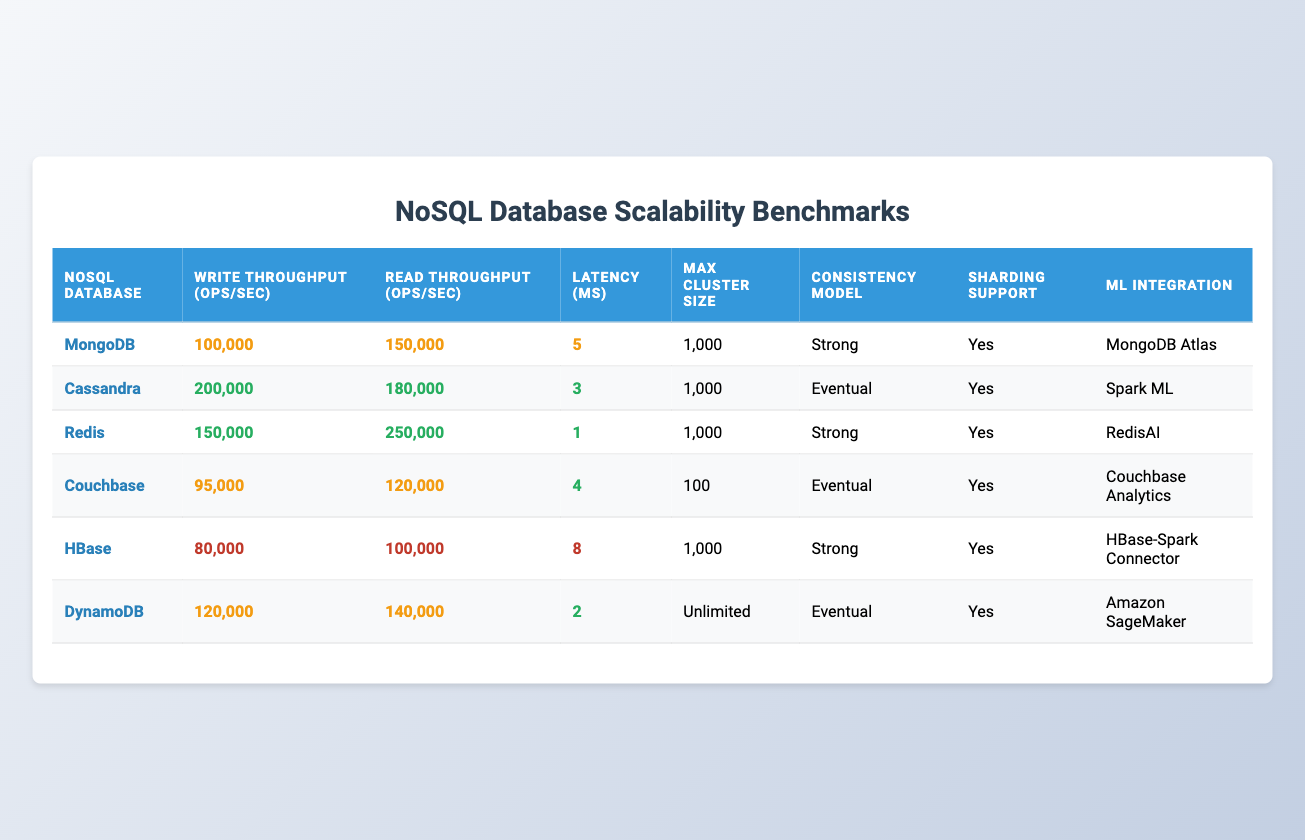What is the write throughput of Cassandra? By looking at the "Write Throughput (ops/sec)" column for Cassandra, the value is clearly listed as 200000 operations per second.
Answer: 200000 Which NoSQL database has the highest read throughput? Reviewing the "Read Throughput (ops/sec)" column, Redis has the highest value at 250000 operations per second.
Answer: Redis What is the average latency for the databases listed? The latencies are 5, 3, 1, 4, 8, and 2 milliseconds, respectively. Summing these values gives 5 + 3 + 1 + 4 + 8 + 2 = 23 ms. Dividing by the number of databases (6), the average latency is 23 / 6 = 3.83 ms.
Answer: 3.83 Is it true that all the NoSQL databases listed support sharding? The "Sharding Support" column for each database shows "Yes", confirming that it is indeed true that all listed databases support sharding.
Answer: Yes Which database has the strongest consistency model? From the "Consistency Model" column, both MongoDB, Redis, and HBase have a strong consistency model, whereas others have eventual consistency.
Answer: MongoDB, Redis, HBase What is the maximum cluster size for Couchbase? The "Max Cluster Size" column indicates that Couchbase can support a maximum cluster size of 100.
Answer: 100 Which NoSQL database has the lowest write throughput? By comparing the "Write Throughput (ops/sec)" column, HBase has the lowest value at 80000 operations per second.
Answer: HBase What is the difference in latency between Redis and HBase? The latency for Redis is 1 ms, and for HBase, it is 8 ms. The difference is calculated as 8 - 1 = 7 ms.
Answer: 7 Which NoSQL database offers unlimited max cluster size? In the "Max Cluster Size" column, DynamoDB is the only database listed with "Unlimited".
Answer: DynamoDB 